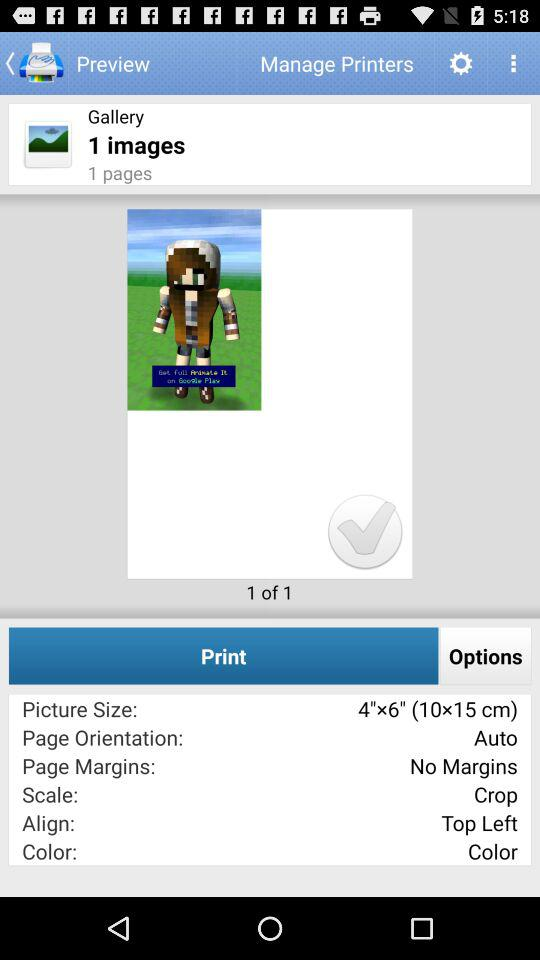What is the scale of the image? The scale of the image is "Crop". 